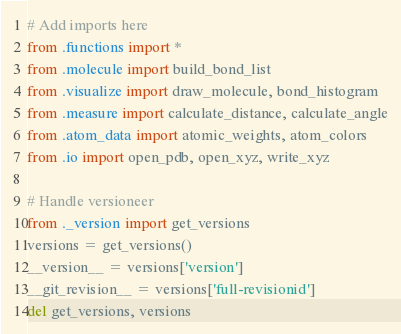<code> <loc_0><loc_0><loc_500><loc_500><_Python_>
# Add imports here
from .functions import *
from .molecule import build_bond_list
from .visualize import draw_molecule, bond_histogram
from .measure import calculate_distance, calculate_angle
from .atom_data import atomic_weights, atom_colors
from .io import open_pdb, open_xyz, write_xyz

# Handle versioneer
from ._version import get_versions
versions = get_versions()
__version__ = versions['version']
__git_revision__ = versions['full-revisionid']
del get_versions, versions
</code> 